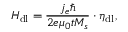<formula> <loc_0><loc_0><loc_500><loc_500>H _ { d l } = \frac { j _ { e } } { 2 e \mu _ { 0 } t M _ { s } } \cdot \eta _ { d l } ,</formula> 